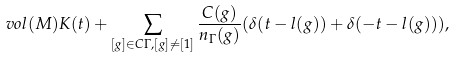Convert formula to latex. <formula><loc_0><loc_0><loc_500><loc_500>v o l ( M ) K ( t ) + \sum _ { [ g ] \in C \Gamma , [ g ] \not = [ 1 ] } \frac { C ( g ) } { n _ { \Gamma } ( g ) } ( \delta ( t - l ( g ) ) + \delta ( - t - l ( g ) ) ) ,</formula> 